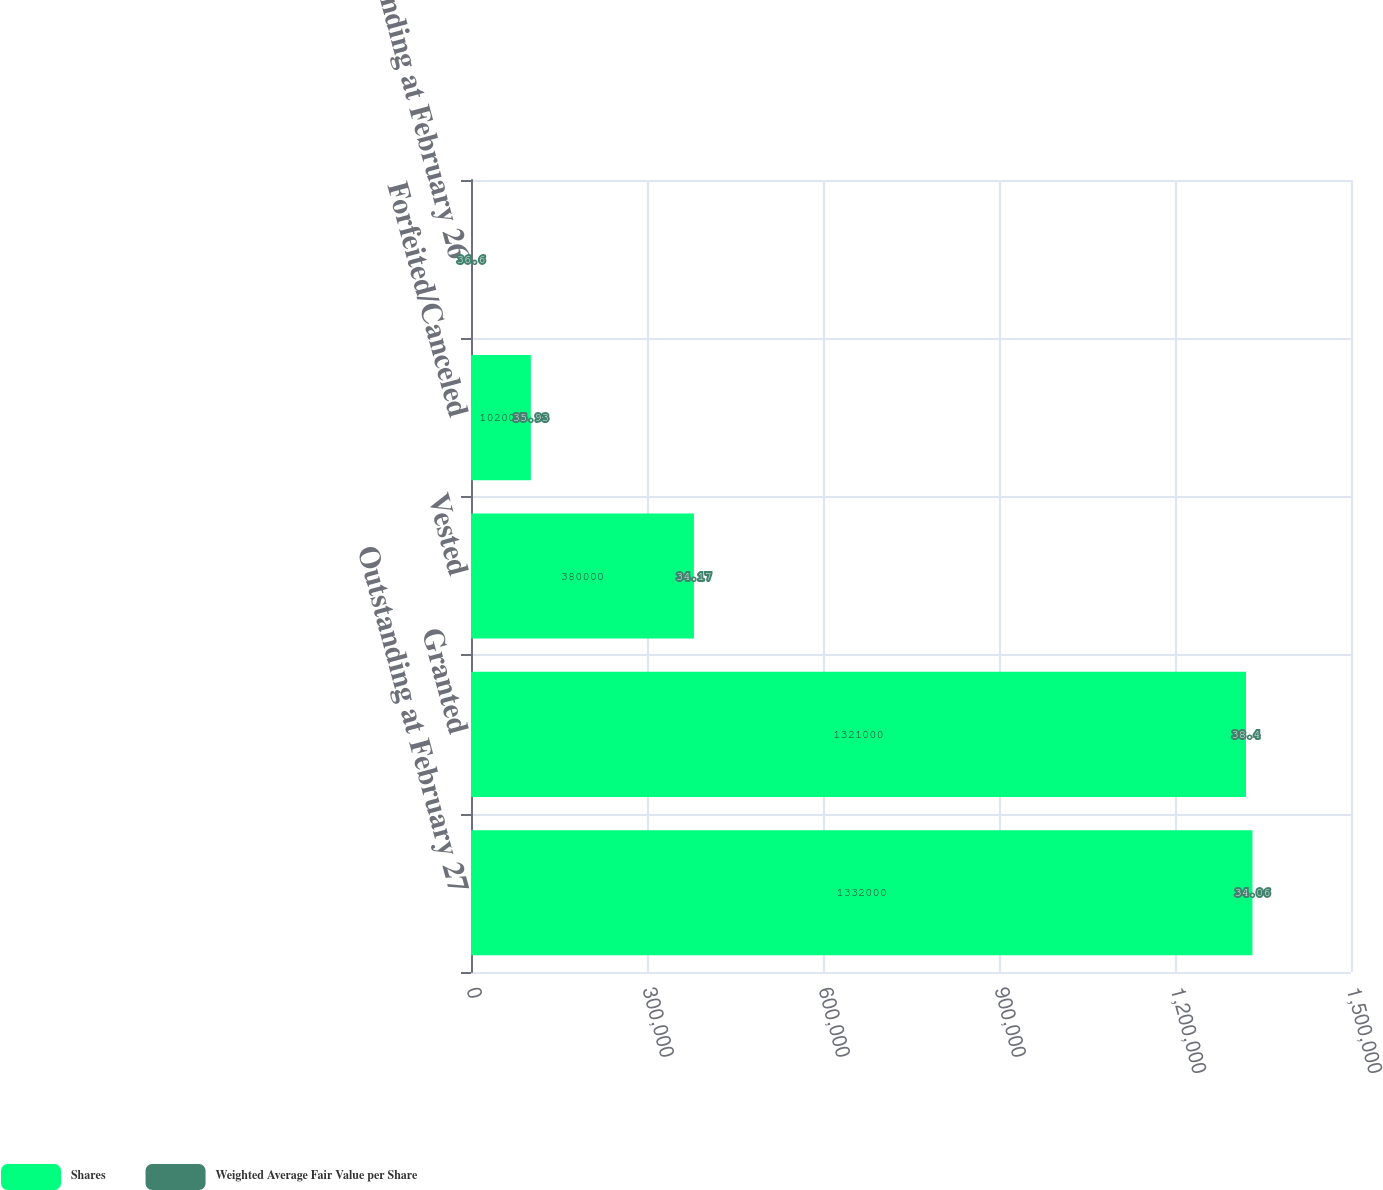<chart> <loc_0><loc_0><loc_500><loc_500><stacked_bar_chart><ecel><fcel>Outstanding at February 27<fcel>Granted<fcel>Vested<fcel>Forfeited/Canceled<fcel>Outstanding at February 26<nl><fcel>Shares<fcel>1.332e+06<fcel>1.321e+06<fcel>380000<fcel>102000<fcel>38.4<nl><fcel>Weighted Average Fair Value per Share<fcel>34.06<fcel>38.4<fcel>34.17<fcel>35.93<fcel>36.6<nl></chart> 